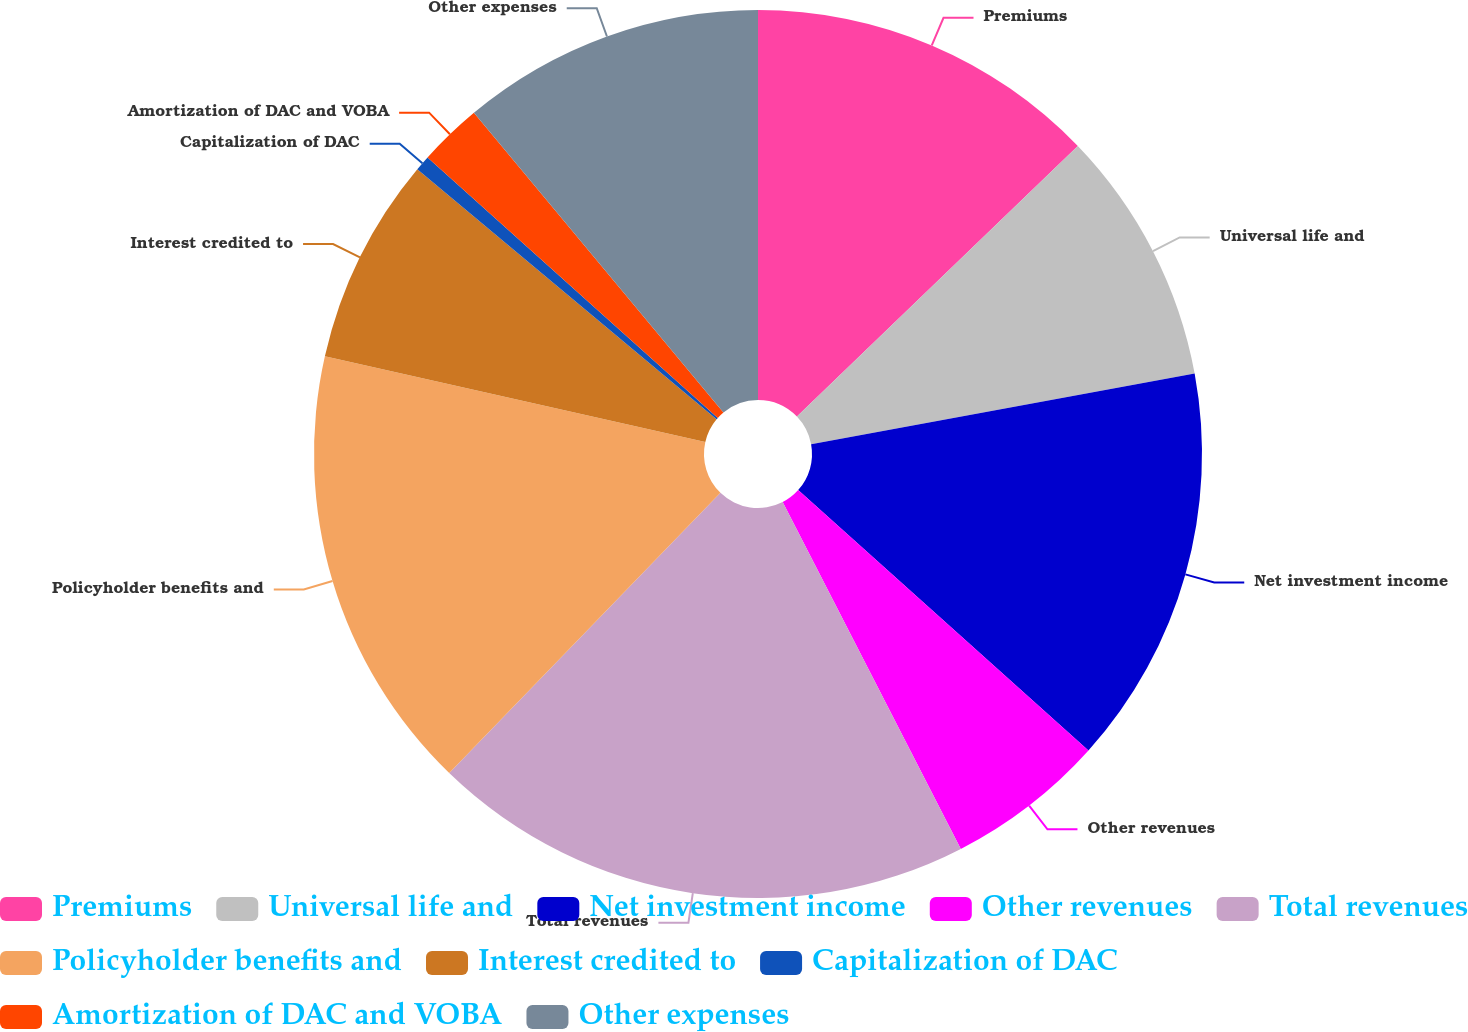Convert chart. <chart><loc_0><loc_0><loc_500><loc_500><pie_chart><fcel>Premiums<fcel>Universal life and<fcel>Net investment income<fcel>Other revenues<fcel>Total revenues<fcel>Policyholder benefits and<fcel>Interest credited to<fcel>Capitalization of DAC<fcel>Amortization of DAC and VOBA<fcel>Other expenses<nl><fcel>12.8%<fcel>9.3%<fcel>14.54%<fcel>5.81%<fcel>19.79%<fcel>16.29%<fcel>7.55%<fcel>0.56%<fcel>2.31%<fcel>11.05%<nl></chart> 